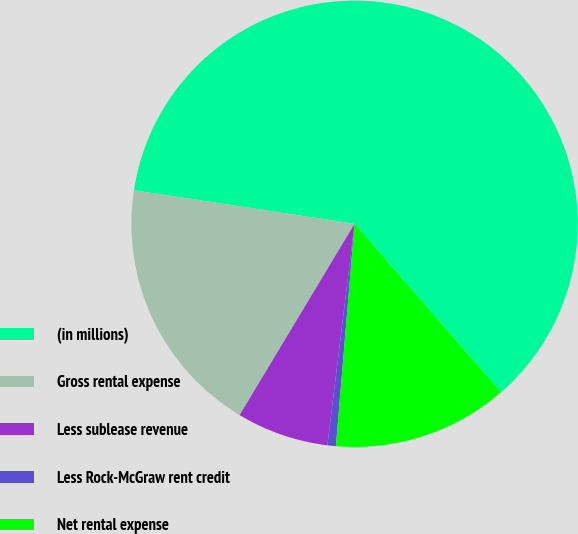Convert chart. <chart><loc_0><loc_0><loc_500><loc_500><pie_chart><fcel>(in millions)<fcel>Gross rental expense<fcel>Less sublease revenue<fcel>Less Rock-McGraw rent credit<fcel>Net rental expense<nl><fcel>61.21%<fcel>18.79%<fcel>6.67%<fcel>0.61%<fcel>12.73%<nl></chart> 